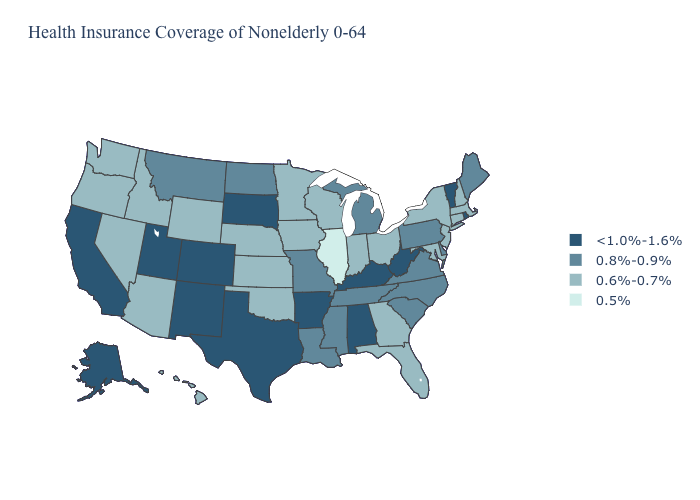Among the states that border Tennessee , does Georgia have the highest value?
Write a very short answer. No. Which states have the lowest value in the MidWest?
Concise answer only. Illinois. Name the states that have a value in the range <1.0%-1.6%?
Quick response, please. Alabama, Alaska, Arkansas, California, Colorado, Kentucky, New Mexico, Rhode Island, South Dakota, Texas, Utah, Vermont, West Virginia. Does the map have missing data?
Be succinct. No. What is the highest value in states that border Florida?
Answer briefly. <1.0%-1.6%. Does Maryland have the same value as Ohio?
Be succinct. Yes. Name the states that have a value in the range 0.5%?
Short answer required. Illinois. Does Alabama have a lower value than Minnesota?
Short answer required. No. Among the states that border New Mexico , does Oklahoma have the lowest value?
Answer briefly. Yes. Name the states that have a value in the range 0.8%-0.9%?
Keep it brief. Delaware, Louisiana, Maine, Michigan, Mississippi, Missouri, Montana, North Carolina, North Dakota, Pennsylvania, South Carolina, Tennessee, Virginia. Is the legend a continuous bar?
Answer briefly. No. Does Louisiana have the same value as New Jersey?
Be succinct. No. Does California have the lowest value in the USA?
Concise answer only. No. Does Montana have the highest value in the West?
Be succinct. No. 